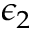Convert formula to latex. <formula><loc_0><loc_0><loc_500><loc_500>\epsilon _ { 2 }</formula> 